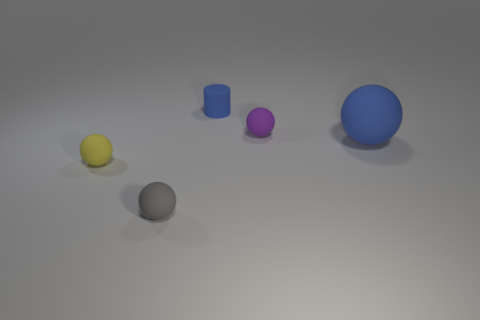Subtract all tiny gray matte balls. How many balls are left? 3 Subtract 1 cylinders. How many cylinders are left? 0 Subtract all yellow balls. How many balls are left? 3 Add 2 tiny gray matte spheres. How many objects exist? 7 Subtract all balls. How many objects are left? 1 Subtract all tiny gray rubber things. Subtract all gray matte things. How many objects are left? 3 Add 1 tiny purple objects. How many tiny purple objects are left? 2 Add 2 small rubber things. How many small rubber things exist? 6 Subtract 0 brown balls. How many objects are left? 5 Subtract all cyan balls. Subtract all green cylinders. How many balls are left? 4 